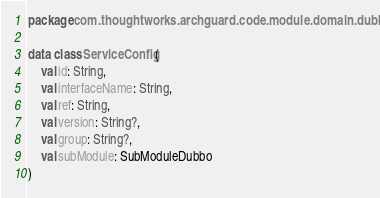Convert code to text. <code><loc_0><loc_0><loc_500><loc_500><_Kotlin_>package com.thoughtworks.archguard.code.module.domain.dubbo

data class ServiceConfig(
    val id: String,
    val interfaceName: String,
    val ref: String,
    val version: String?,
    val group: String?,
    val subModule: SubModuleDubbo
)
</code> 